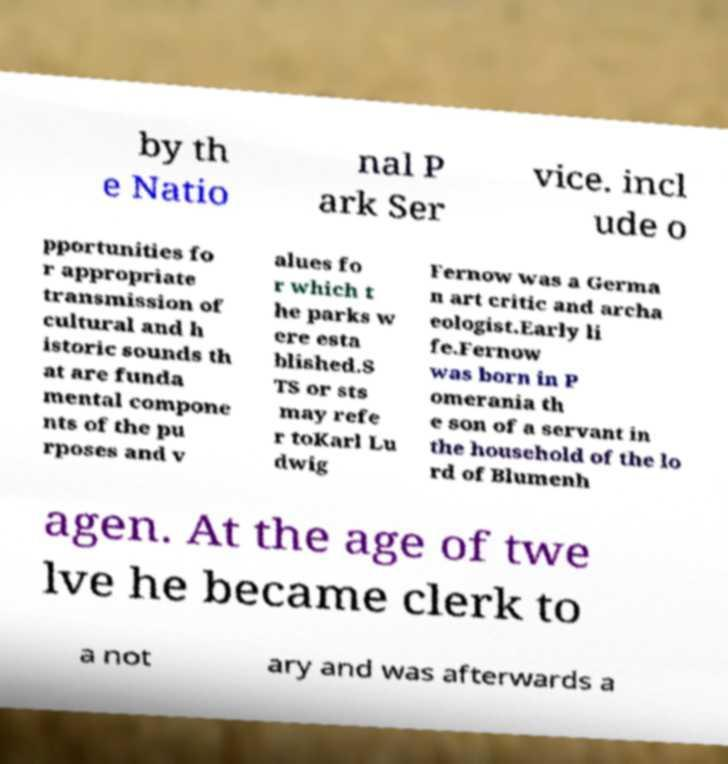Can you accurately transcribe the text from the provided image for me? by th e Natio nal P ark Ser vice. incl ude o pportunities fo r appropriate transmission of cultural and h istoric sounds th at are funda mental compone nts of the pu rposes and v alues fo r which t he parks w ere esta blished.S TS or sts may refe r toKarl Lu dwig Fernow was a Germa n art critic and archa eologist.Early li fe.Fernow was born in P omerania th e son of a servant in the household of the lo rd of Blumenh agen. At the age of twe lve he became clerk to a not ary and was afterwards a 